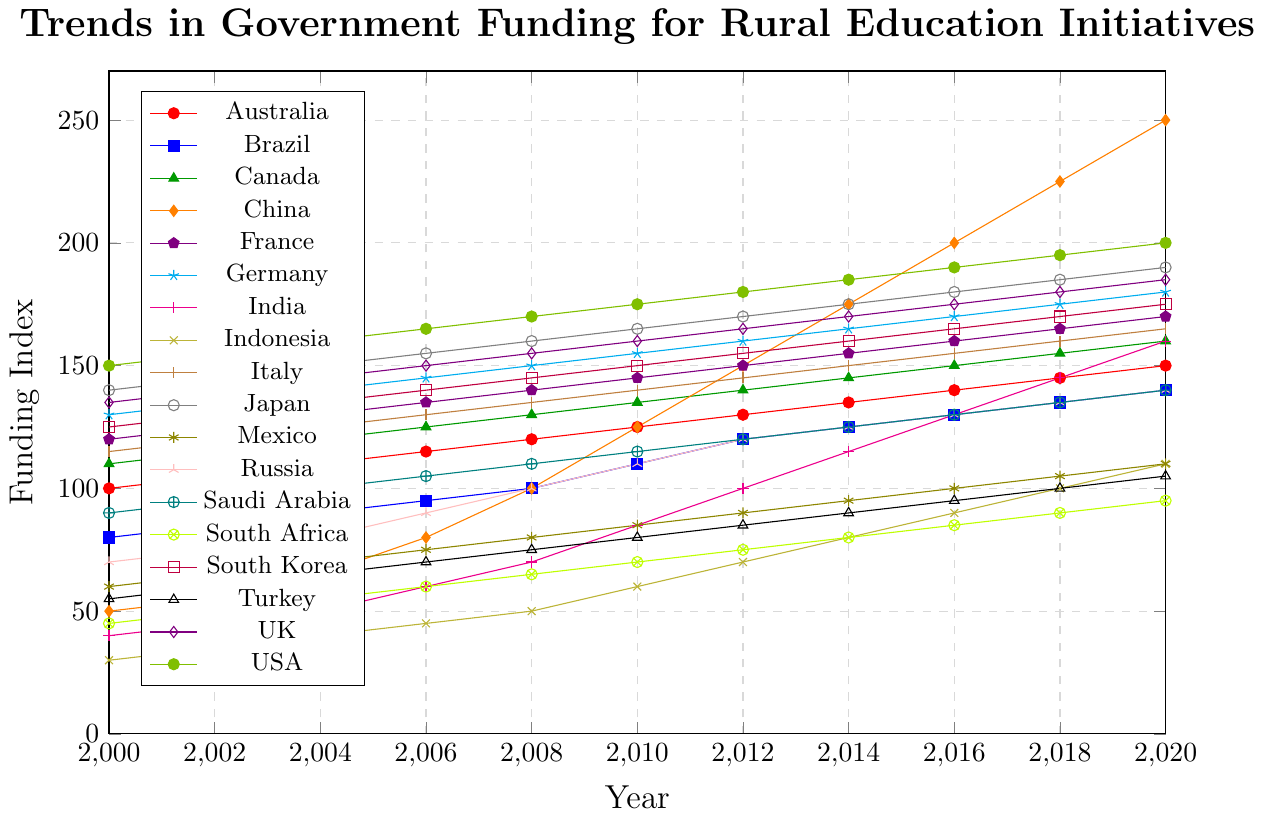Which G20 country had the highest funding for rural education initiatives in 2020? By looking at the plot, identify the country with the highest data point in the year 2020, which is China with a funding index of 250.
Answer: China Which country showed the most significant increase in funding from 2000 to 2020? Calculate the difference in funding index for each country between 2000 and 2020, then determine which country has the largest difference. China had an increase from 50 to 250, which is an increase of 200.
Answer: China How did the funding trend for India change from 2000 to 2020? Look at the line corresponding to India and note its upward trend year by year from 40 in 2000 to 160 in 2020. India showed a consistent increase in funding over this period.
Answer: Increased Compare the funding levels of Brazil and South Africa in 2014. Which country had a higher funding index? Observe the plot for the year 2014 and compare the data points for Brazil and South Africa, with Brazil at 125 and South Africa at 80.
Answer: Brazil Between which two consecutive years did the USA show the most significant increase in funding? Analyze the USA's funding line and calculate the year-by-year differences. The most significant increase is from 2014 (185) to 2016 (190), which is an increase of 5.
Answer: 2014 to 2016 What is the average funding index for Australia over the years shown? Sum the funding indices for each year for Australia and divide by the number of years: (100 + 105 + 110 + 115 + 120 + 125 + 130 + 135 + 140 + 145 + 150) / 11 = 122.27.
Answer: 122.27 In which year did Japan first reach a funding index of 170? Examine the plot for Japan and find the first occurrence of the 170 data point. It occurred in 2012.
Answer: 2012 How does Saudi Arabia’s funding trend compare to that of Russia from 2000 to 2020? Observe the lines for Saudi Arabia and Russia. Both countries show a similar upward trend, starting from 90 and 70 respectively in 2000 and reaching 140 in 2020. However, Russia's increase is slightly more consistent.
Answer: Similar upward trend Which country had the smallest increase in funding from 2000 to 2020? Calculate the difference for each country and find the smallest one. Indonesia had an increase from 30 to 110, which is an increase of 80.
Answer: Indonesia What is the median funding index for Italy across all years? List Italy's funding indices: [115, 120, 125, 130, 135, 140, 145, 150, 155, 160, 165], sort them, and find the middle value. Since there are 11 values, the median is the 6th value, which is 140.
Answer: 140 